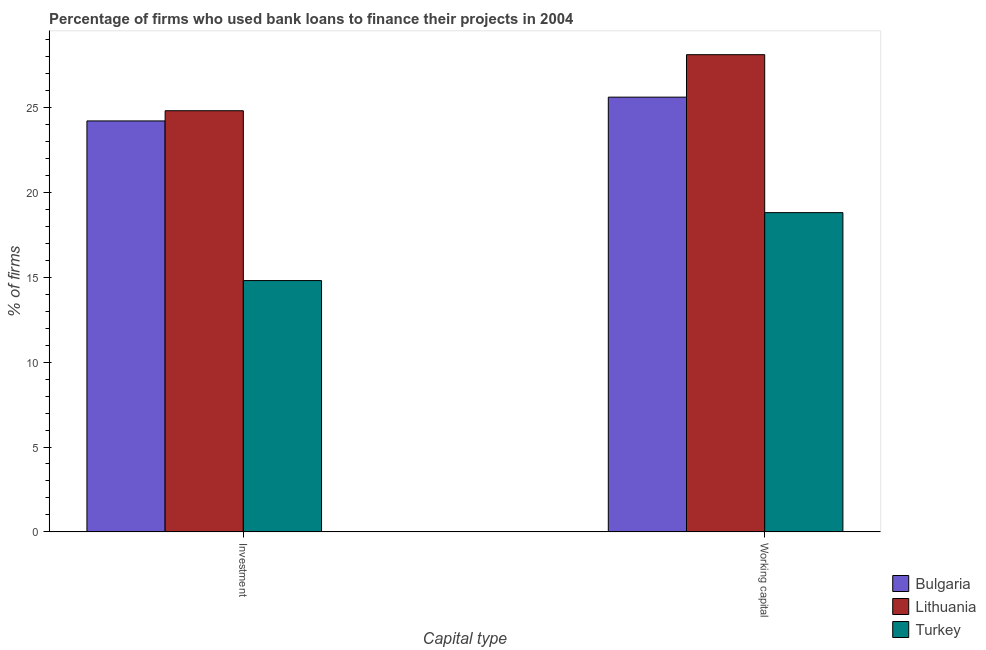How many groups of bars are there?
Ensure brevity in your answer.  2. What is the label of the 2nd group of bars from the left?
Your answer should be compact. Working capital. What is the percentage of firms using banks to finance working capital in Lithuania?
Make the answer very short. 28.1. Across all countries, what is the maximum percentage of firms using banks to finance investment?
Your response must be concise. 24.8. In which country was the percentage of firms using banks to finance working capital maximum?
Provide a succinct answer. Lithuania. What is the total percentage of firms using banks to finance investment in the graph?
Your answer should be very brief. 63.8. What is the difference between the percentage of firms using banks to finance investment in Turkey and that in Bulgaria?
Your response must be concise. -9.4. What is the difference between the percentage of firms using banks to finance working capital in Bulgaria and the percentage of firms using banks to finance investment in Turkey?
Give a very brief answer. 10.8. What is the average percentage of firms using banks to finance investment per country?
Your response must be concise. 21.27. What is the difference between the percentage of firms using banks to finance working capital and percentage of firms using banks to finance investment in Lithuania?
Keep it short and to the point. 3.3. What is the ratio of the percentage of firms using banks to finance working capital in Bulgaria to that in Lithuania?
Offer a terse response. 0.91. In how many countries, is the percentage of firms using banks to finance investment greater than the average percentage of firms using banks to finance investment taken over all countries?
Provide a short and direct response. 2. What does the 1st bar from the left in Investment represents?
Provide a succinct answer. Bulgaria. What does the 2nd bar from the right in Working capital represents?
Your answer should be very brief. Lithuania. How many bars are there?
Provide a succinct answer. 6. Are all the bars in the graph horizontal?
Your answer should be compact. No. What is the difference between two consecutive major ticks on the Y-axis?
Provide a short and direct response. 5. Are the values on the major ticks of Y-axis written in scientific E-notation?
Provide a succinct answer. No. Where does the legend appear in the graph?
Your answer should be very brief. Bottom right. How many legend labels are there?
Keep it short and to the point. 3. What is the title of the graph?
Your answer should be very brief. Percentage of firms who used bank loans to finance their projects in 2004. What is the label or title of the X-axis?
Keep it short and to the point. Capital type. What is the label or title of the Y-axis?
Your answer should be very brief. % of firms. What is the % of firms of Bulgaria in Investment?
Make the answer very short. 24.2. What is the % of firms of Lithuania in Investment?
Your answer should be compact. 24.8. What is the % of firms of Turkey in Investment?
Your answer should be very brief. 14.8. What is the % of firms of Bulgaria in Working capital?
Keep it short and to the point. 25.6. What is the % of firms of Lithuania in Working capital?
Keep it short and to the point. 28.1. What is the % of firms of Turkey in Working capital?
Provide a succinct answer. 18.8. Across all Capital type, what is the maximum % of firms in Bulgaria?
Offer a terse response. 25.6. Across all Capital type, what is the maximum % of firms of Lithuania?
Give a very brief answer. 28.1. Across all Capital type, what is the minimum % of firms in Bulgaria?
Make the answer very short. 24.2. Across all Capital type, what is the minimum % of firms of Lithuania?
Provide a short and direct response. 24.8. Across all Capital type, what is the minimum % of firms of Turkey?
Keep it short and to the point. 14.8. What is the total % of firms of Bulgaria in the graph?
Give a very brief answer. 49.8. What is the total % of firms in Lithuania in the graph?
Keep it short and to the point. 52.9. What is the total % of firms in Turkey in the graph?
Offer a very short reply. 33.6. What is the difference between the % of firms of Bulgaria in Investment and that in Working capital?
Your answer should be very brief. -1.4. What is the difference between the % of firms in Lithuania in Investment and that in Working capital?
Keep it short and to the point. -3.3. What is the difference between the % of firms in Turkey in Investment and that in Working capital?
Your response must be concise. -4. What is the difference between the % of firms of Bulgaria in Investment and the % of firms of Lithuania in Working capital?
Ensure brevity in your answer.  -3.9. What is the difference between the % of firms of Bulgaria in Investment and the % of firms of Turkey in Working capital?
Keep it short and to the point. 5.4. What is the difference between the % of firms of Lithuania in Investment and the % of firms of Turkey in Working capital?
Offer a very short reply. 6. What is the average % of firms of Bulgaria per Capital type?
Provide a succinct answer. 24.9. What is the average % of firms of Lithuania per Capital type?
Your answer should be compact. 26.45. What is the difference between the % of firms of Bulgaria and % of firms of Lithuania in Investment?
Offer a terse response. -0.6. What is the difference between the % of firms in Bulgaria and % of firms in Turkey in Investment?
Offer a terse response. 9.4. What is the difference between the % of firms of Lithuania and % of firms of Turkey in Investment?
Offer a very short reply. 10. What is the difference between the % of firms of Bulgaria and % of firms of Lithuania in Working capital?
Provide a short and direct response. -2.5. What is the ratio of the % of firms in Bulgaria in Investment to that in Working capital?
Your answer should be compact. 0.95. What is the ratio of the % of firms in Lithuania in Investment to that in Working capital?
Your answer should be compact. 0.88. What is the ratio of the % of firms of Turkey in Investment to that in Working capital?
Your response must be concise. 0.79. What is the difference between the highest and the second highest % of firms in Bulgaria?
Your answer should be compact. 1.4. What is the difference between the highest and the lowest % of firms in Turkey?
Make the answer very short. 4. 